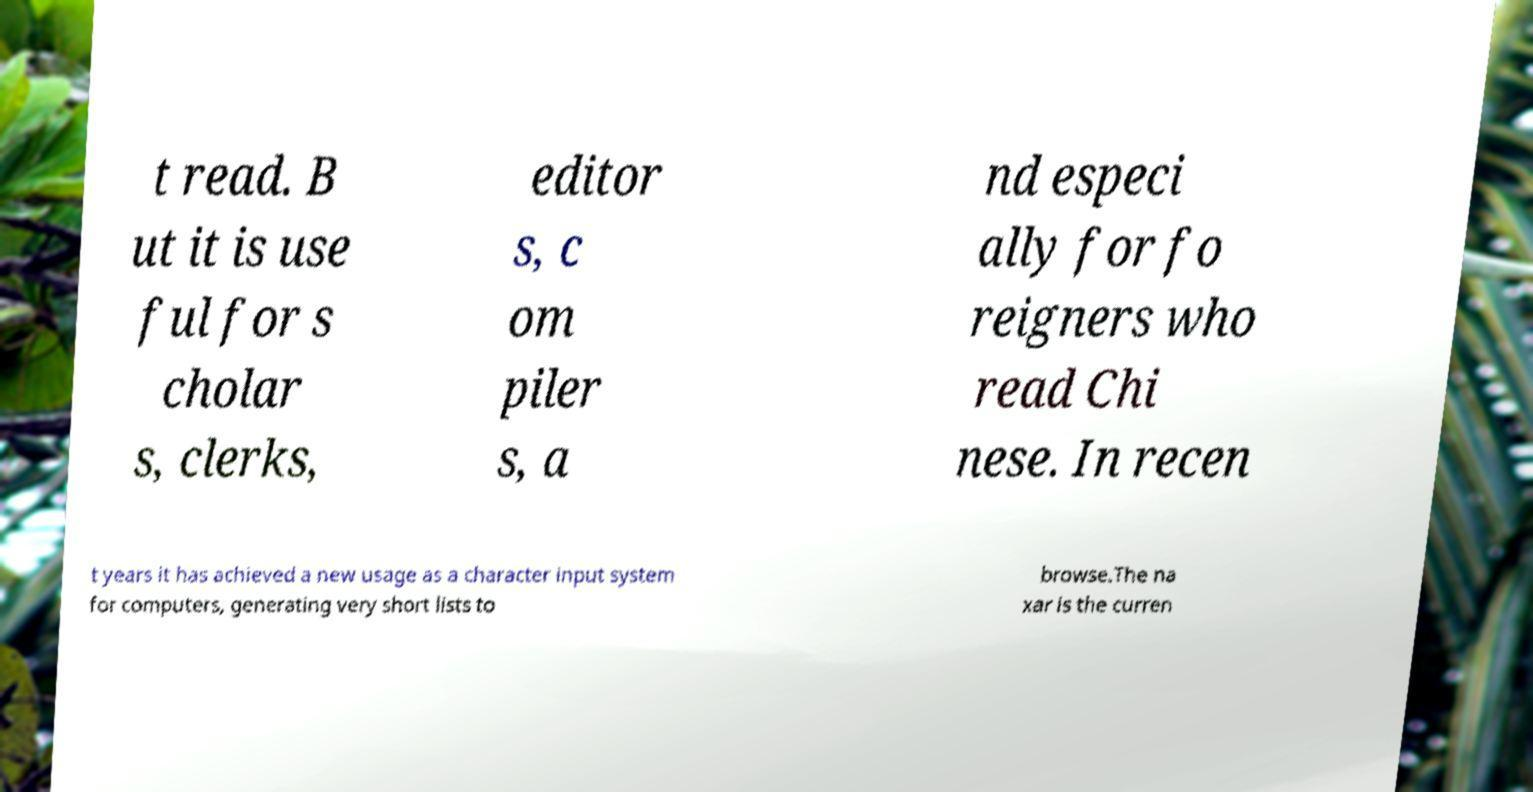What messages or text are displayed in this image? I need them in a readable, typed format. t read. B ut it is use ful for s cholar s, clerks, editor s, c om piler s, a nd especi ally for fo reigners who read Chi nese. In recen t years it has achieved a new usage as a character input system for computers, generating very short lists to browse.The na xar is the curren 